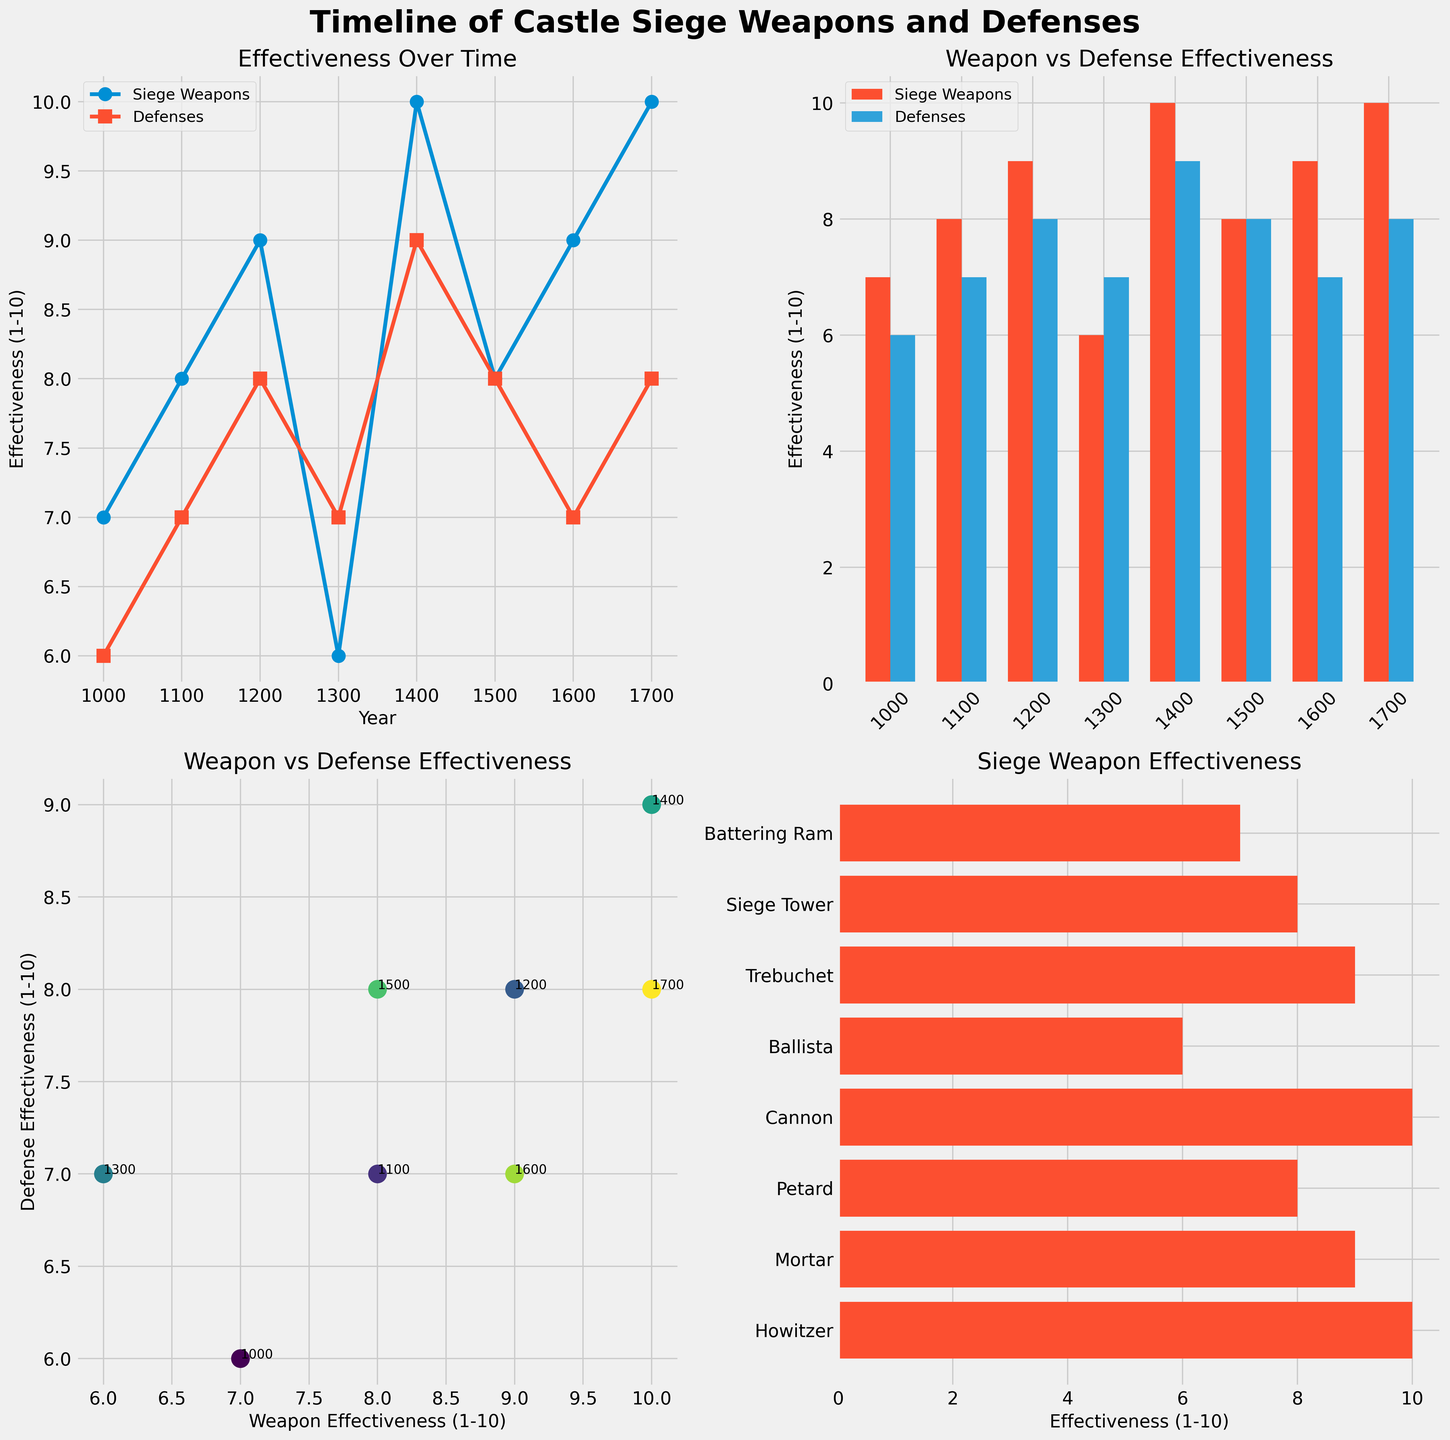Who has the higher effectiveness in the year 1200, siege weapons or defenses? Look at the line plot subplot. For the year 1200, observe the effectiveness values for both siege weapons and defenses. Siege weapons have a value of 9 while defenses have a value of 8. Thus, siege weapons have a higher effectiveness.
Answer: Siege Weapons Between which two decades does the defense effectiveness see the highest increase? Refer to the line plot subplot. Calculate the differences in effectiveness values between consecutive decades for defenses. The highest increase is between 1000 and 1100, where the effectiveness increases from 6 to 7.
Answer: 1000-1100 Which year shows the most significant difference between weapon and defense effectiveness? Compare the differences between the two effectiveness values for each year using the line plot and bar plot subplots. In 1300, the difference is the greatest, with weapon effectiveness at 6 and defense effectiveness at 7, a difference of 1.
Answer: 1300 How does the effectiveness of the cannon compare to the star fort design? In the horizontal bar plot, check the effectiveness values for the cannon and star fort design. The cannon has an effectiveness of 10, while the star fort design has an effectiveness of 9. Thus, the cannon is more effective.
Answer: Cannon is higher What is the trend in the scatter plot regarding the relationship between siege weapon effectiveness and defense effectiveness? The scatter plot shows correlated data points. Siege weapon effectiveness and defense effectiveness tend to increase together from lower-left to upper-right.
Answer: Positive correlation Which siege weapon has the highest effectiveness and what is its defensive countermeasure? Look at the top value in the horizontal bar plot. The cannon, with an effectiveness of 10, has the highest effectiveness, and its defensive countermeasure is the star fort design.
Answer: Cannon, Star Fort Design What is the average effectiveness of siege weapons from 1000 to 1700? Calculate the sum of siege weapon effectiveness values (7+8+9+6+10+8+9+10) and divide it by the number of years (8). The sum is 67, and the average is 67/8 = 8.375.
Answer: 8.375 Which subplots show effectiveness data with annotations of specific years? Look through the subplots for annotations marking the years. The scatter plot has annotations with specific years noted next to each data point.
Answer: Scatter plot What is the difference in effectiveness between the petard and its corresponding defensive innovation in 1500? Locate the petard and its corresponding defensive innovation on the bar plot. Petard has an effectiveness of 8 and the ravelin has an effectiveness of 8 as well. The difference is 0.
Answer: 0 When do siege weapons and defenses reach their peak effectiveness in the data provided? Examine the line plot to find the highest points for both siege weapons and defenses. Both reach their peak effectiveness at different times: the cannon in 1400 for siege weapons (value 10) and star fort design in 1500 for defenses (value 9).
Answer: 1400 for siege weapons, 1500 for defenses 